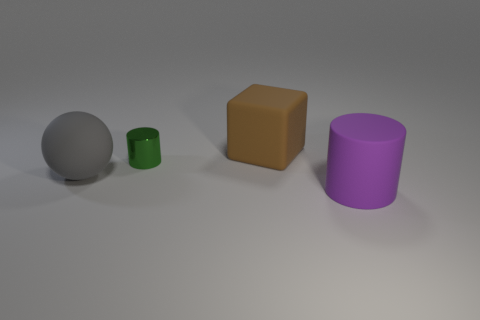Add 1 tiny blue metallic cylinders. How many objects exist? 5 Subtract all green cylinders. How many cylinders are left? 1 Subtract all large cylinders. Subtract all brown cubes. How many objects are left? 2 Add 2 small green metal cylinders. How many small green metal cylinders are left? 3 Add 2 balls. How many balls exist? 3 Subtract 0 green spheres. How many objects are left? 4 Subtract all cubes. How many objects are left? 3 Subtract 1 cylinders. How many cylinders are left? 1 Subtract all green cylinders. Subtract all gray balls. How many cylinders are left? 1 Subtract all yellow blocks. How many blue balls are left? 0 